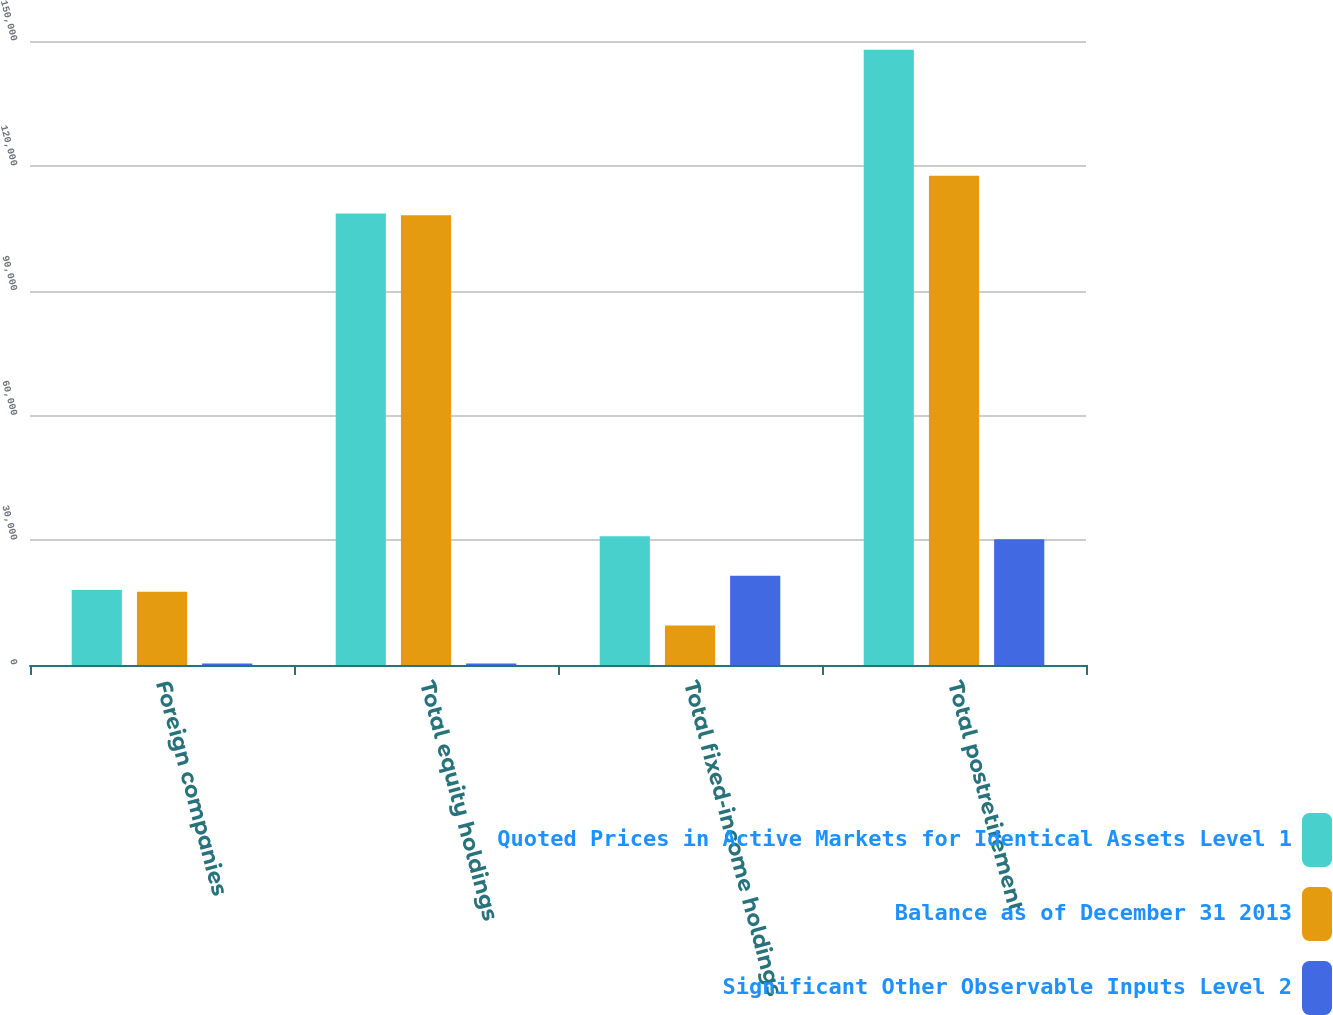Convert chart to OTSL. <chart><loc_0><loc_0><loc_500><loc_500><stacked_bar_chart><ecel><fcel>Foreign companies<fcel>Total equity holdings<fcel>Total fixed-income holdings<fcel>Total postretirement<nl><fcel>Quoted Prices in Active Markets for Identical Assets Level 1<fcel>18010<fcel>108509<fcel>30964<fcel>147875<nl><fcel>Balance as of December 31 2013<fcel>17630<fcel>108129<fcel>9488<fcel>117617<nl><fcel>Significant Other Observable Inputs Level 2<fcel>380<fcel>380<fcel>21476<fcel>30258<nl></chart> 